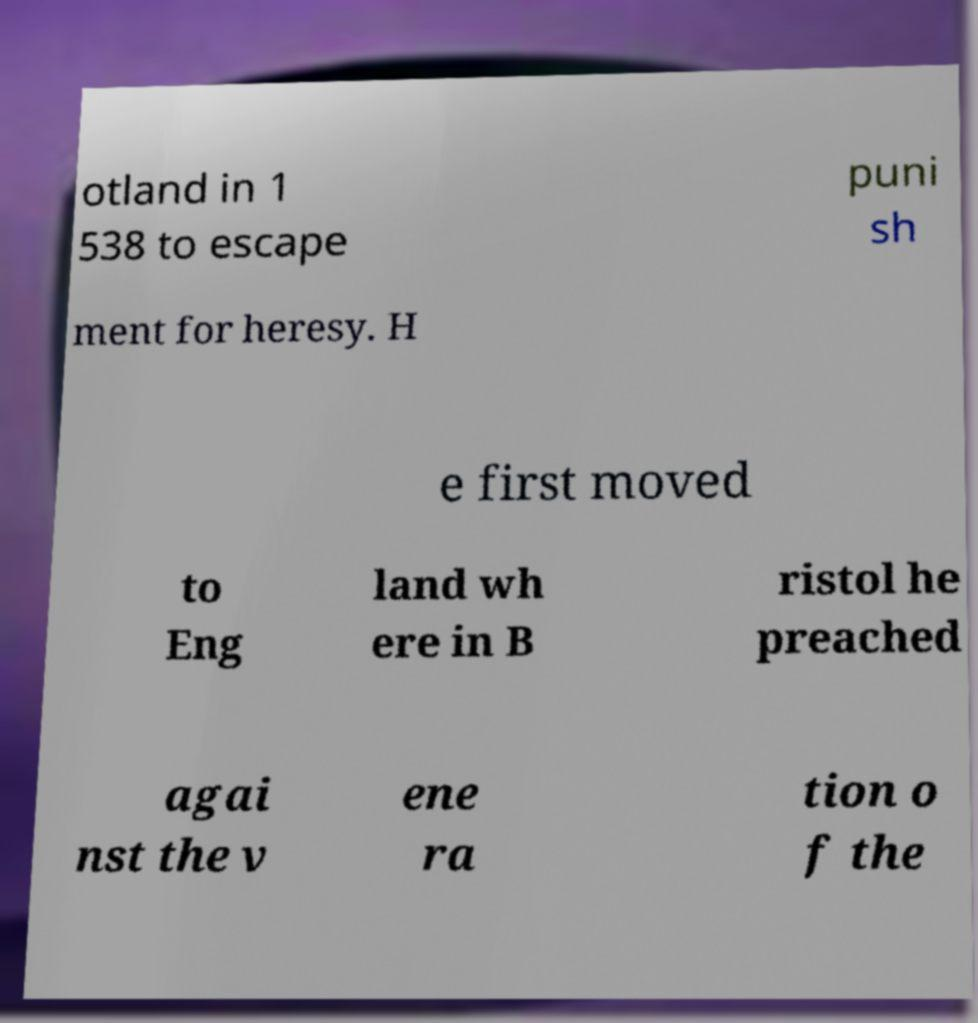For documentation purposes, I need the text within this image transcribed. Could you provide that? otland in 1 538 to escape puni sh ment for heresy. H e first moved to Eng land wh ere in B ristol he preached agai nst the v ene ra tion o f the 